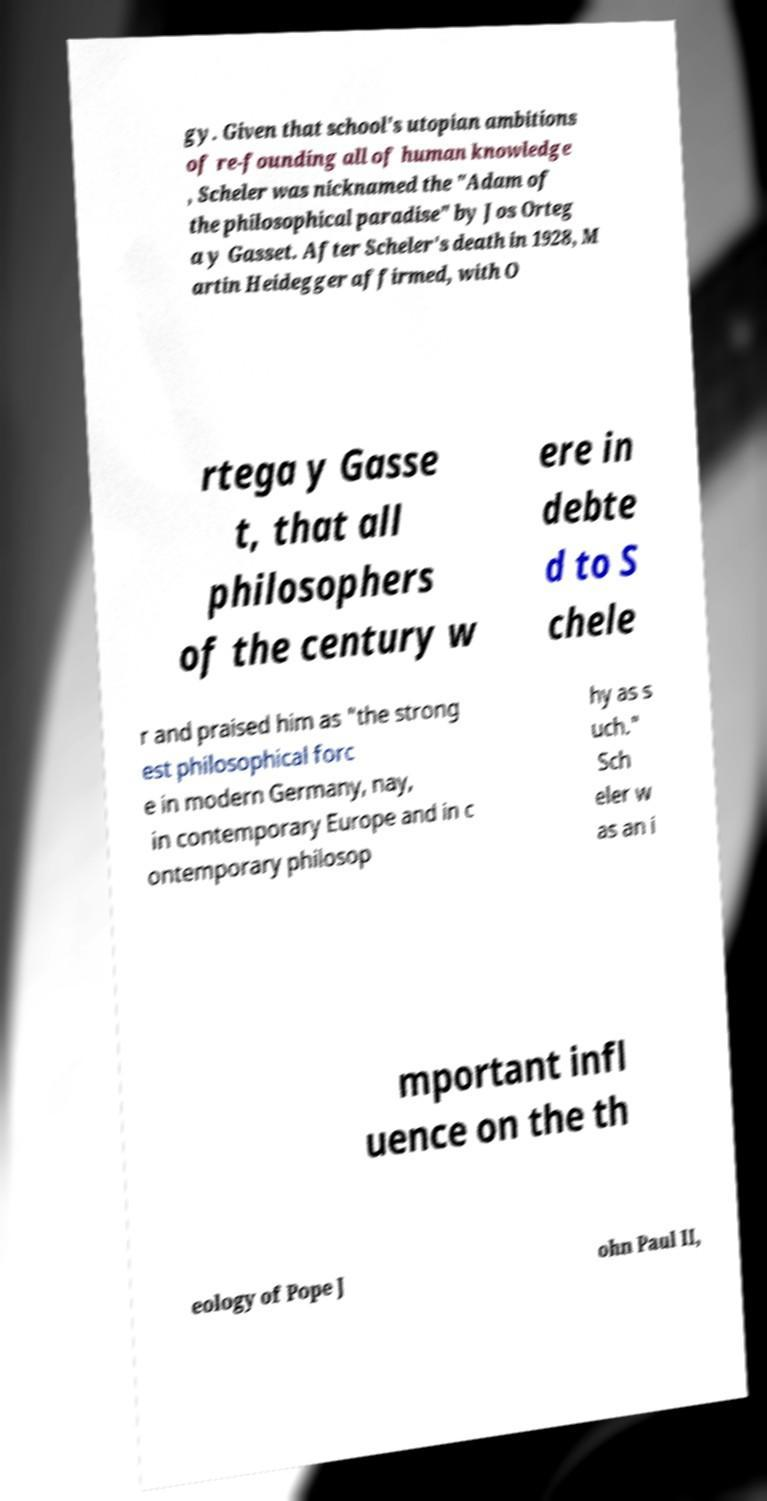For documentation purposes, I need the text within this image transcribed. Could you provide that? gy. Given that school's utopian ambitions of re-founding all of human knowledge , Scheler was nicknamed the "Adam of the philosophical paradise" by Jos Orteg a y Gasset. After Scheler's death in 1928, M artin Heidegger affirmed, with O rtega y Gasse t, that all philosophers of the century w ere in debte d to S chele r and praised him as "the strong est philosophical forc e in modern Germany, nay, in contemporary Europe and in c ontemporary philosop hy as s uch." Sch eler w as an i mportant infl uence on the th eology of Pope J ohn Paul II, 